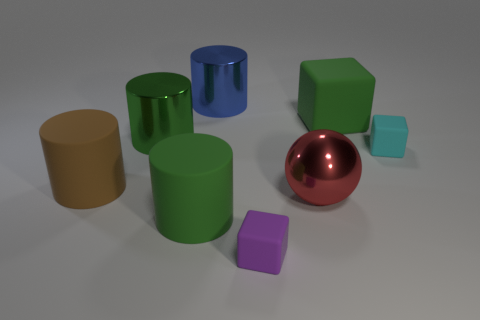There is a metallic object that is in front of the small thing that is on the right side of the big green thing on the right side of the big blue shiny object; what size is it?
Provide a short and direct response. Large. There is a red thing that is the same size as the blue shiny cylinder; what is its material?
Provide a succinct answer. Metal. Is there another rubber block that has the same size as the green cube?
Make the answer very short. No. Does the metal object that is in front of the cyan thing have the same size as the large block?
Ensure brevity in your answer.  Yes. There is a thing that is to the left of the small cyan rubber object and to the right of the large red metal object; what is its shape?
Your response must be concise. Cube. Are there more big metallic things that are behind the big red metal thing than big matte blocks?
Make the answer very short. Yes. There is a cyan cube that is made of the same material as the purple object; what size is it?
Offer a terse response. Small. How many big metal cylinders are the same color as the shiny ball?
Your answer should be very brief. 0. Do the rubber cube that is in front of the big red ball and the large matte block have the same color?
Your answer should be very brief. No. Are there an equal number of tiny cyan things on the left side of the blue cylinder and shiny spheres that are in front of the big red metal sphere?
Your answer should be very brief. Yes. 